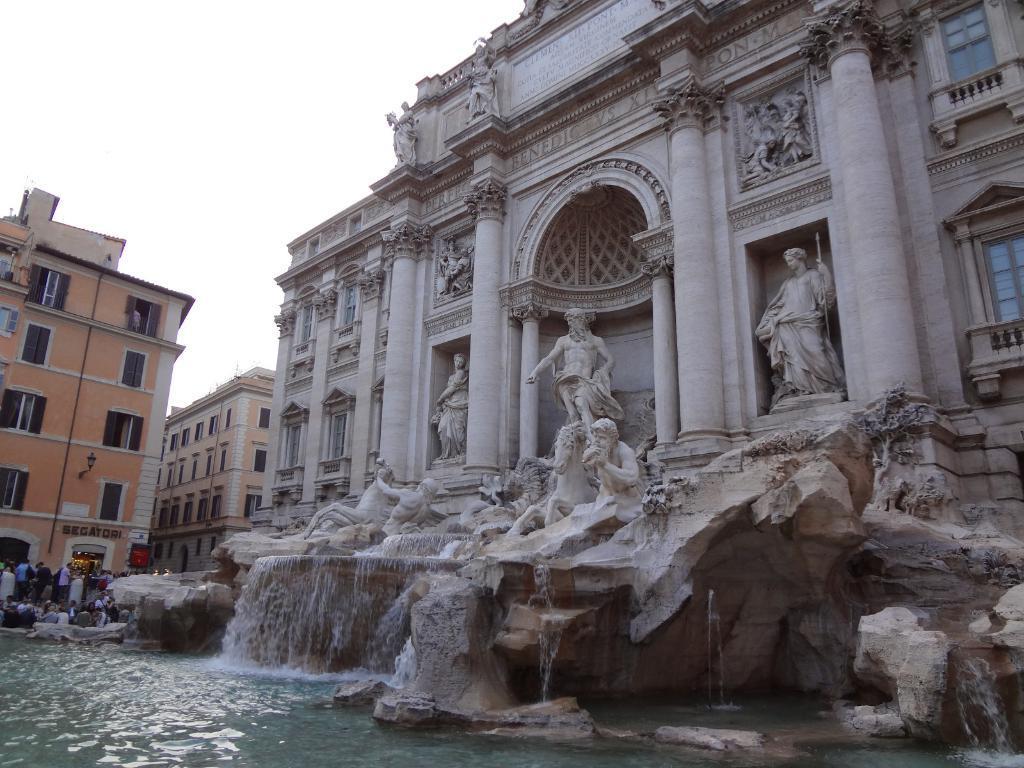How would you summarize this image in a sentence or two? Here we can see buildings. In-front of this building there are sculptures and water. To these buildings there are windows. Here we can see people. 